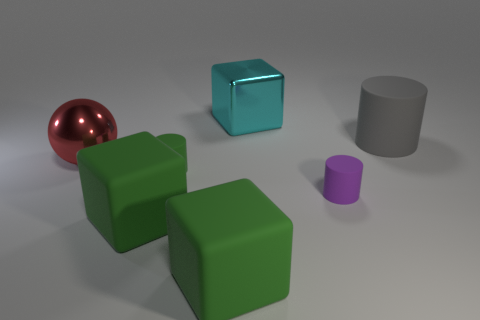Add 2 tiny purple objects. How many objects exist? 9 Subtract all big cylinders. How many cylinders are left? 2 Subtract all red cubes. Subtract all brown cylinders. How many cubes are left? 3 Subtract all gray cylinders. How many cyan blocks are left? 1 Subtract all gray cylinders. How many cylinders are left? 2 Subtract 1 cylinders. How many cylinders are left? 2 Subtract all matte cubes. Subtract all large red spheres. How many objects are left? 4 Add 1 big things. How many big things are left? 6 Add 4 red metallic objects. How many red metallic objects exist? 5 Subtract 0 yellow balls. How many objects are left? 7 